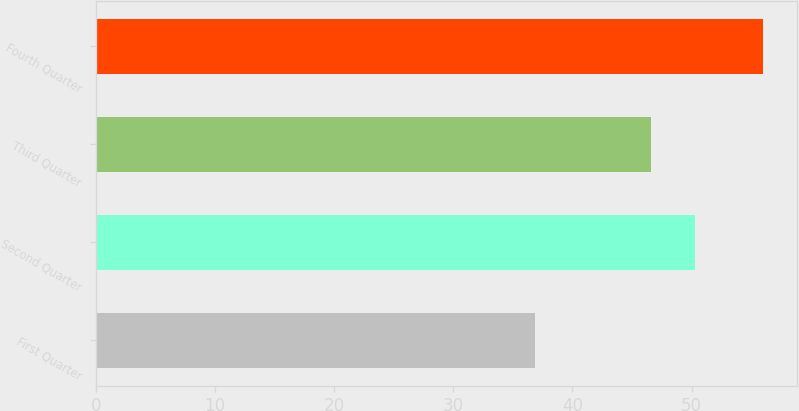<chart> <loc_0><loc_0><loc_500><loc_500><bar_chart><fcel>First Quarter<fcel>Second Quarter<fcel>Third Quarter<fcel>Fourth Quarter<nl><fcel>36.89<fcel>50.26<fcel>46.61<fcel>56.01<nl></chart> 